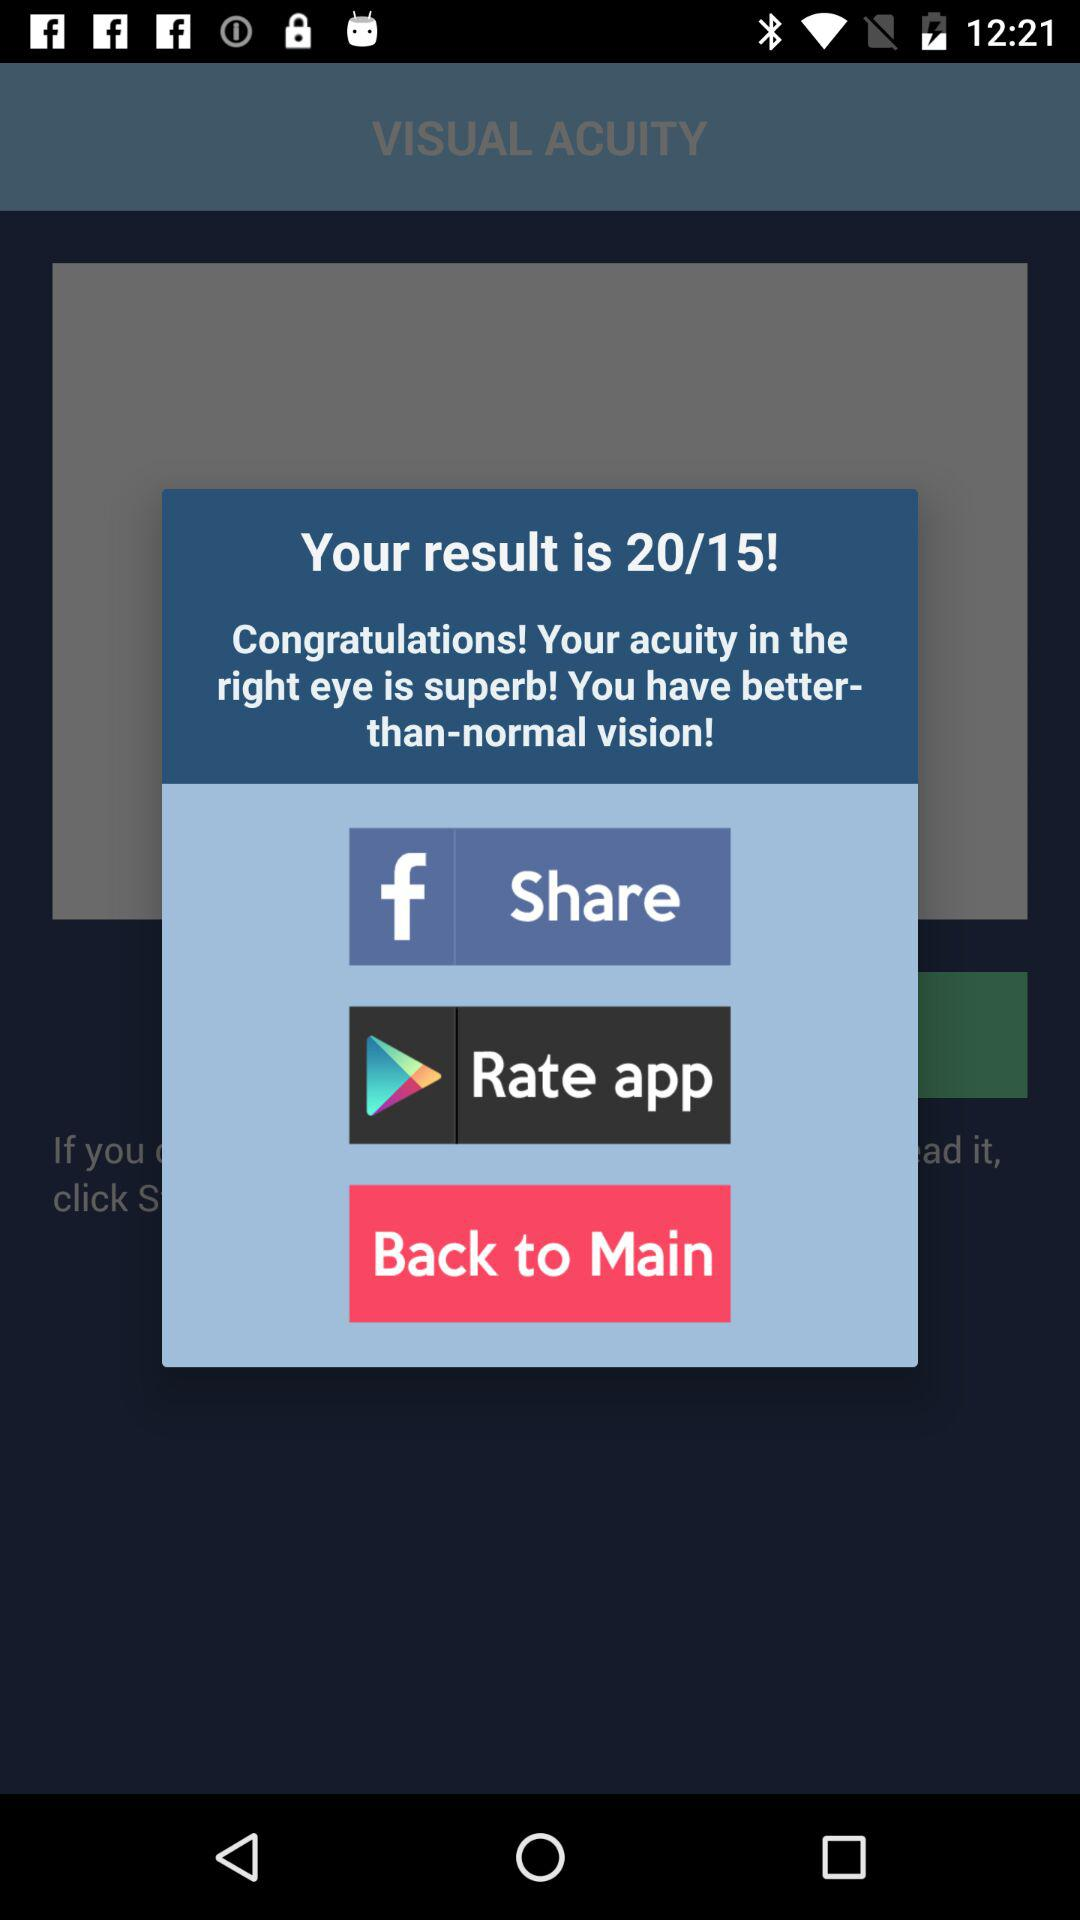Through what application can we rate? We can rate the application through Google Play. 